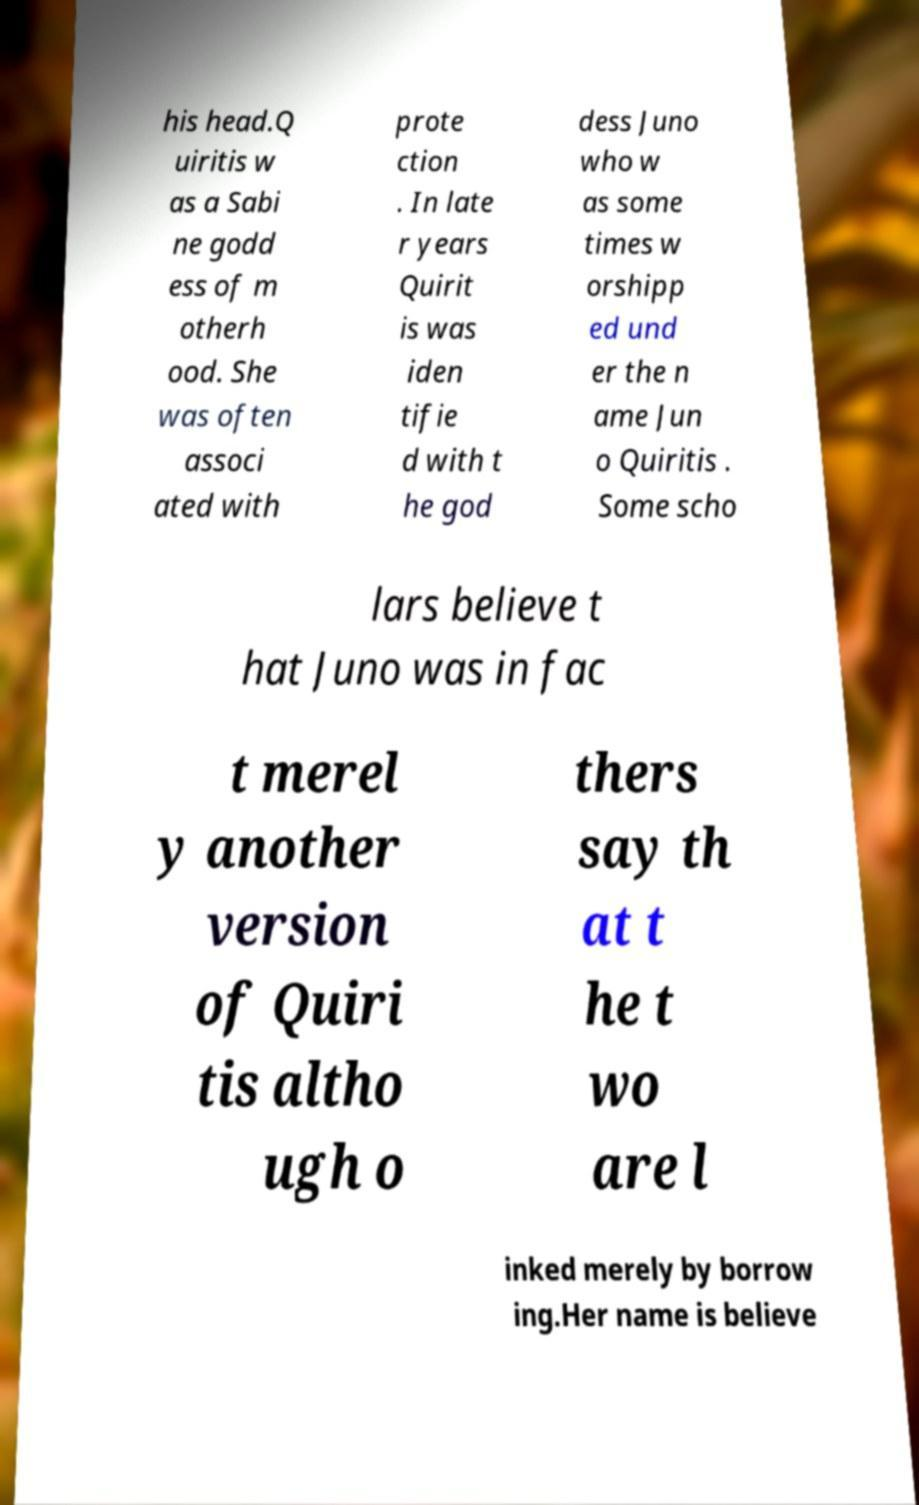There's text embedded in this image that I need extracted. Can you transcribe it verbatim? his head.Q uiritis w as a Sabi ne godd ess of m otherh ood. She was often associ ated with prote ction . In late r years Quirit is was iden tifie d with t he god dess Juno who w as some times w orshipp ed und er the n ame Jun o Quiritis . Some scho lars believe t hat Juno was in fac t merel y another version of Quiri tis altho ugh o thers say th at t he t wo are l inked merely by borrow ing.Her name is believe 